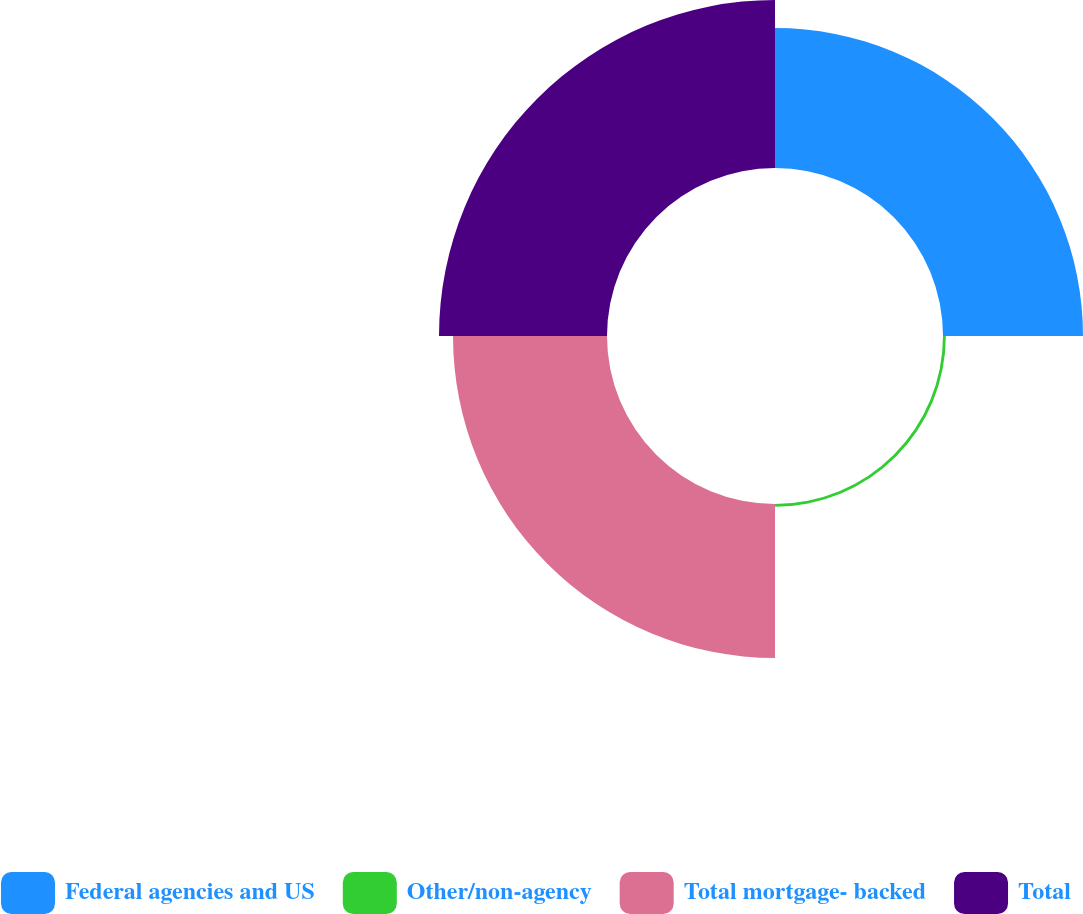Convert chart to OTSL. <chart><loc_0><loc_0><loc_500><loc_500><pie_chart><fcel>Federal agencies and US<fcel>Other/non-agency<fcel>Total mortgage- backed<fcel>Total<nl><fcel>30.12%<fcel>0.61%<fcel>33.13%<fcel>36.14%<nl></chart> 